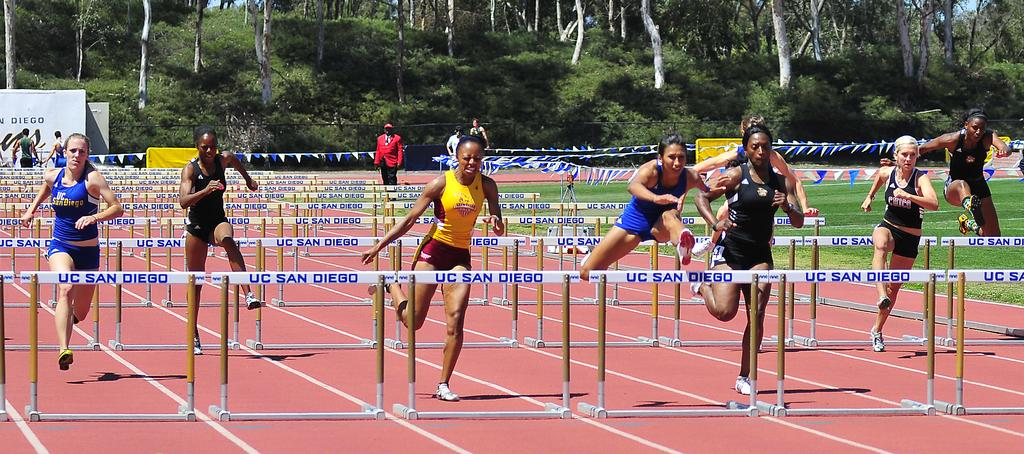<image>
Share a concise interpretation of the image provided. The hurdles are labeled in blue UC SAN DIEGO. 